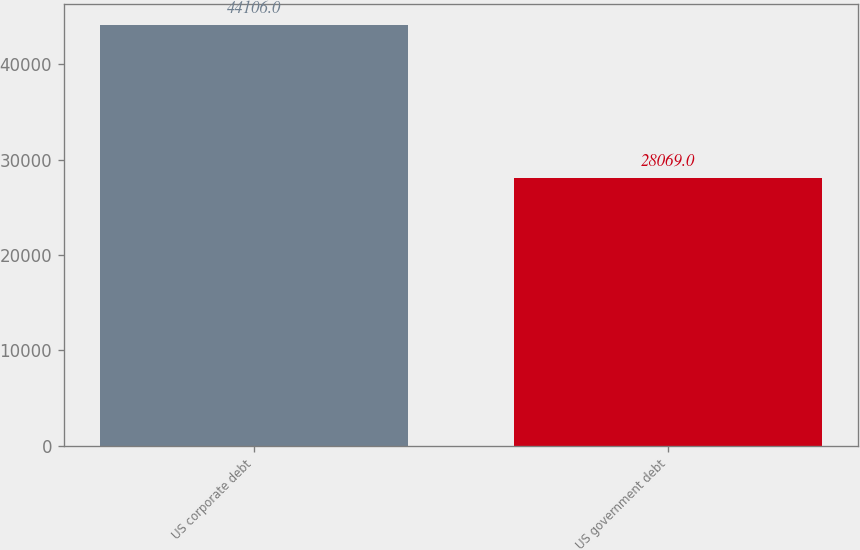Convert chart to OTSL. <chart><loc_0><loc_0><loc_500><loc_500><bar_chart><fcel>US corporate debt<fcel>US government debt<nl><fcel>44106<fcel>28069<nl></chart> 